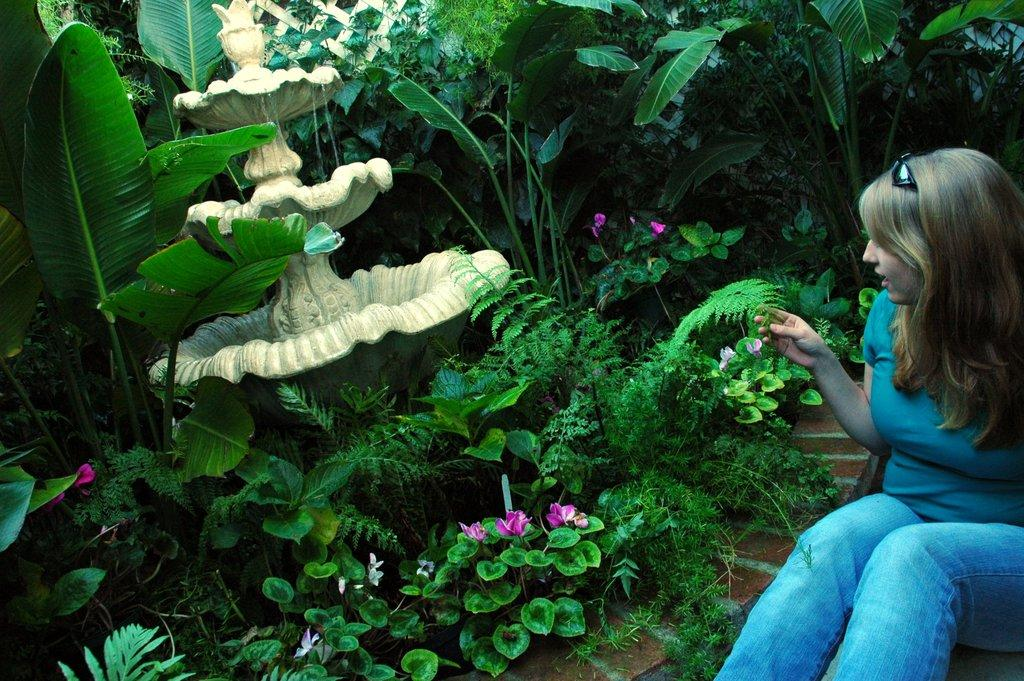What is the woman doing in the image? The woman is sitting on the right side of the image. What type of vegetation can be seen on the left side of the image? There are plants, trees, and flowers on the left side of the image. What can be seen in the middle of the image? There appears to be a fountain in the middle of the image. How many children are involved in the crime depicted in the image? There is no crime or children present in the image. What type of copy machine is visible in the image? There is no copy machine present in the image. 